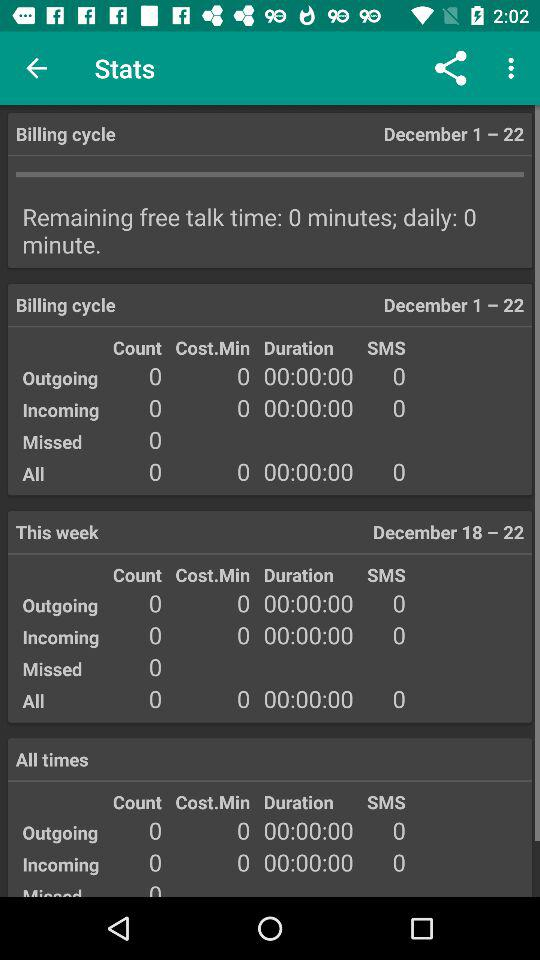How many calls were made between 18-22 December? The calls that were made between 18-22 December is 0. 